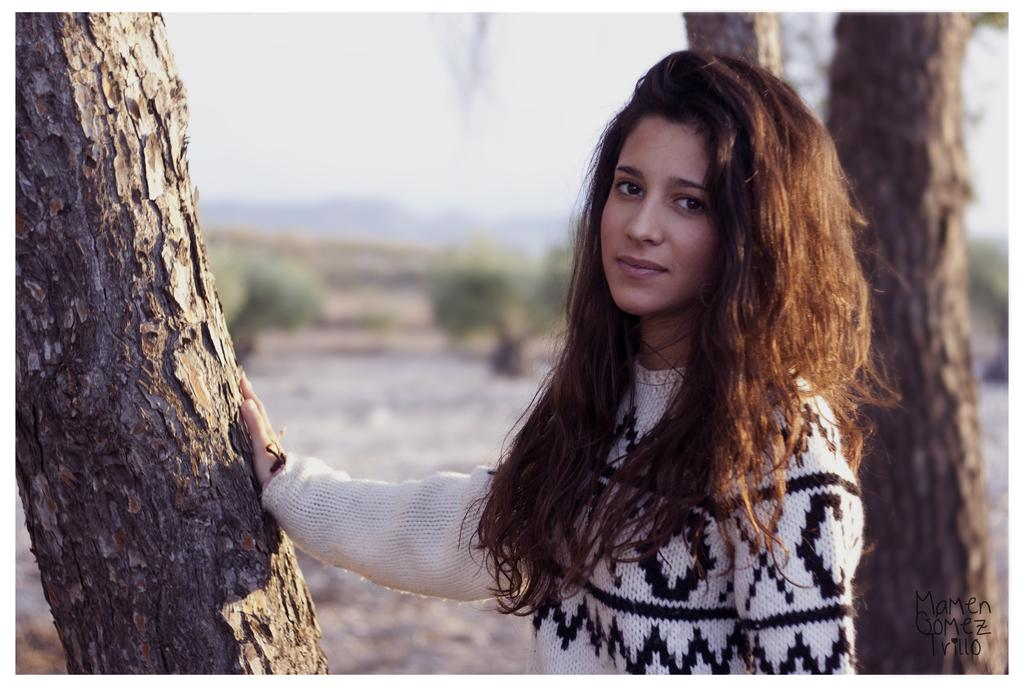Who is present in the image? There is a woman in the image. What is the woman wearing? The woman is wearing a sweater. What can be seen on the left side of the image? There is a bark of a tree on the left side of the image. What is visible in the background of the image? There are trees, land, and the sky visible in the background of the image. What type of celery is being used as a prop in the image? There is no celery present in the image. Can you tell me how many monkeys are sitting on the woman's shoulder in the image? There are no monkeys present in the image. 